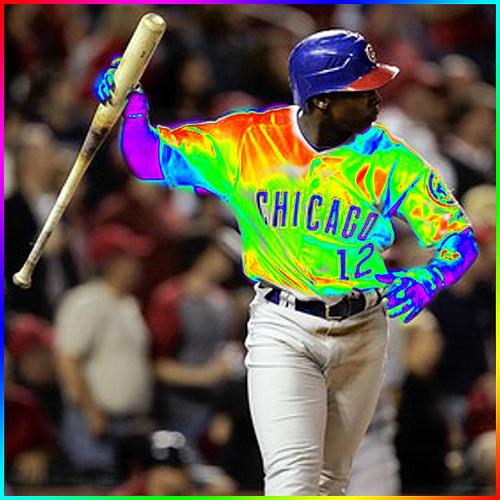What is this man holding in his hand?
Short answer required. Bat. Is this the player's natural skin color?
Write a very short answer. No. Has this picture been manipulated?
Answer briefly. Yes. 